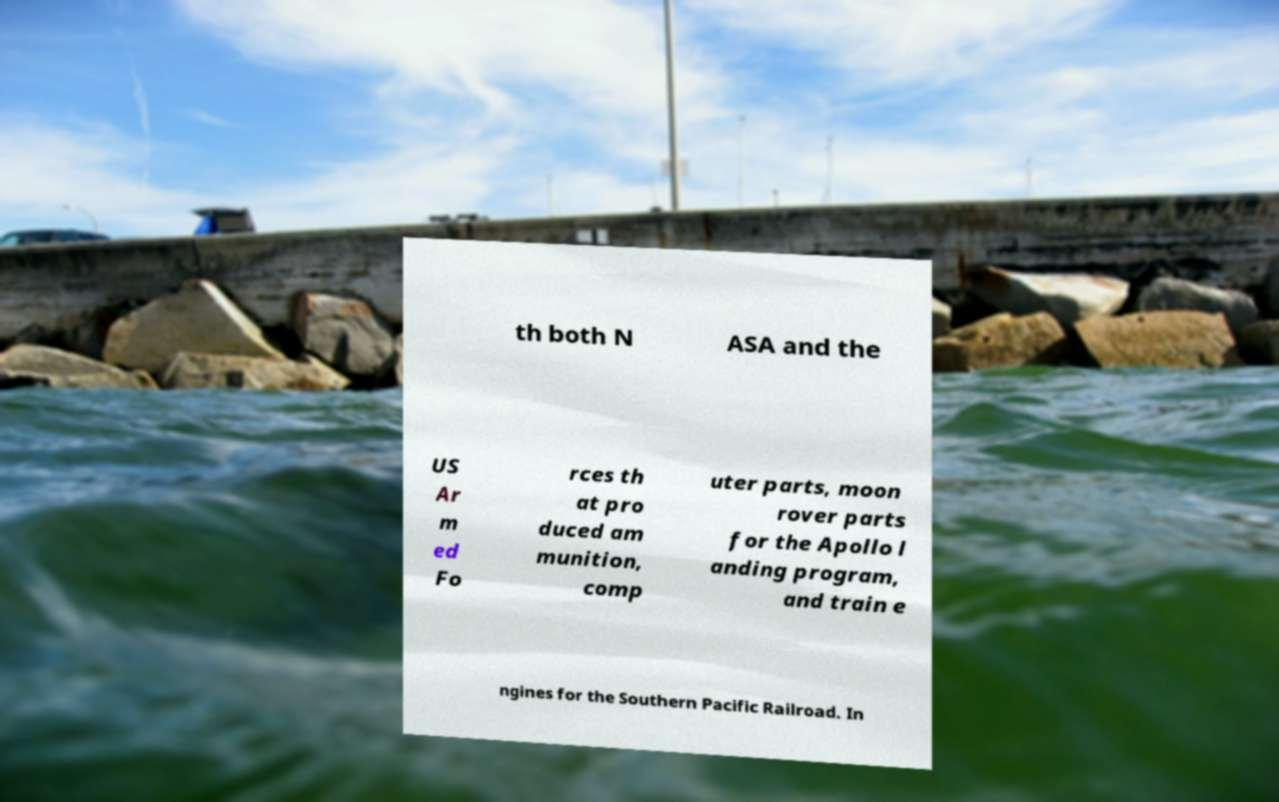For documentation purposes, I need the text within this image transcribed. Could you provide that? th both N ASA and the US Ar m ed Fo rces th at pro duced am munition, comp uter parts, moon rover parts for the Apollo l anding program, and train e ngines for the Southern Pacific Railroad. In 